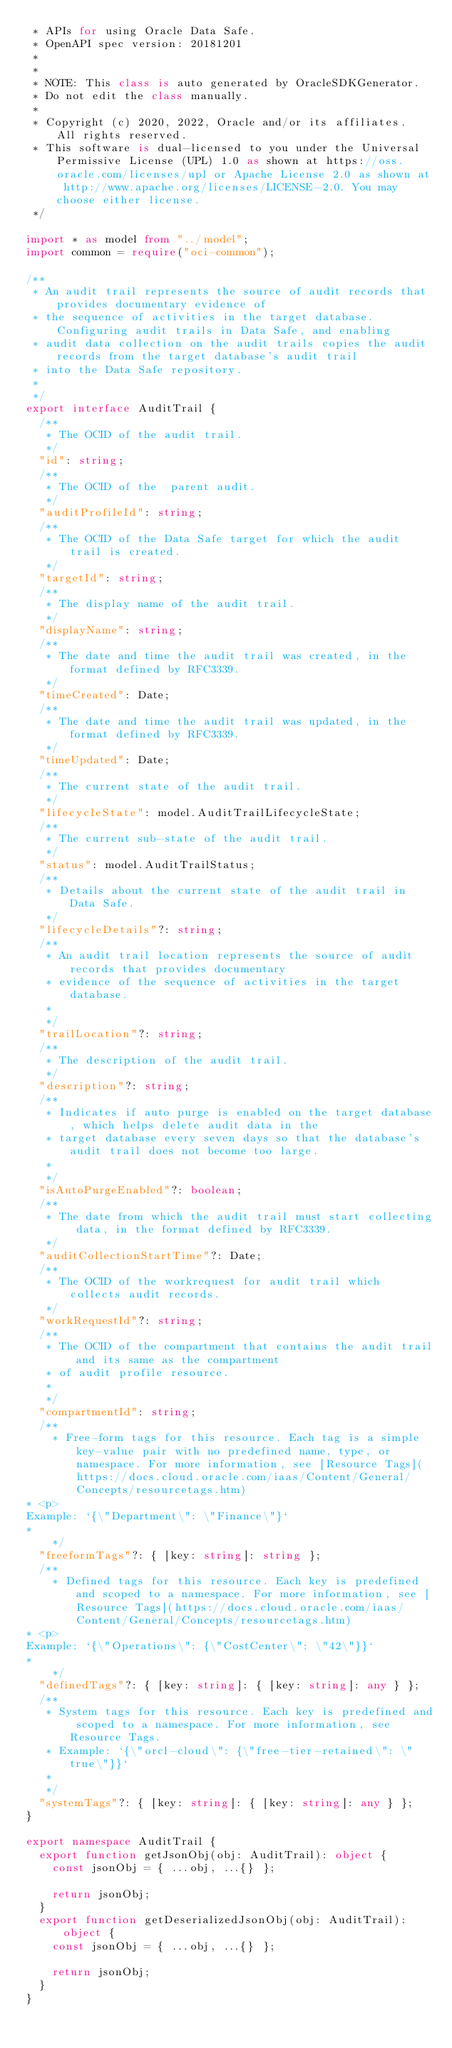Convert code to text. <code><loc_0><loc_0><loc_500><loc_500><_TypeScript_> * APIs for using Oracle Data Safe.
 * OpenAPI spec version: 20181201
 *
 *
 * NOTE: This class is auto generated by OracleSDKGenerator.
 * Do not edit the class manually.
 *
 * Copyright (c) 2020, 2022, Oracle and/or its affiliates.  All rights reserved.
 * This software is dual-licensed to you under the Universal Permissive License (UPL) 1.0 as shown at https://oss.oracle.com/licenses/upl or Apache License 2.0 as shown at http://www.apache.org/licenses/LICENSE-2.0. You may choose either license.
 */

import * as model from "../model";
import common = require("oci-common");

/**
 * An audit trail represents the source of audit records that provides documentary evidence of
 * the sequence of activities in the target database. Configuring audit trails in Data Safe, and enabling
 * audit data collection on the audit trails copies the audit records from the target database's audit trail
 * into the Data Safe repository.
 *
 */
export interface AuditTrail {
  /**
   * The OCID of the audit trail.
   */
  "id": string;
  /**
   * The OCID of the  parent audit.
   */
  "auditProfileId": string;
  /**
   * The OCID of the Data Safe target for which the audit trail is created.
   */
  "targetId": string;
  /**
   * The display name of the audit trail.
   */
  "displayName": string;
  /**
   * The date and time the audit trail was created, in the format defined by RFC3339.
   */
  "timeCreated": Date;
  /**
   * The date and time the audit trail was updated, in the format defined by RFC3339.
   */
  "timeUpdated": Date;
  /**
   * The current state of the audit trail.
   */
  "lifecycleState": model.AuditTrailLifecycleState;
  /**
   * The current sub-state of the audit trail.
   */
  "status": model.AuditTrailStatus;
  /**
   * Details about the current state of the audit trail in Data Safe.
   */
  "lifecycleDetails"?: string;
  /**
   * An audit trail location represents the source of audit records that provides documentary
   * evidence of the sequence of activities in the target database.
   *
   */
  "trailLocation"?: string;
  /**
   * The description of the audit trail.
   */
  "description"?: string;
  /**
   * Indicates if auto purge is enabled on the target database, which helps delete audit data in the
   * target database every seven days so that the database's audit trail does not become too large.
   *
   */
  "isAutoPurgeEnabled"?: boolean;
  /**
   * The date from which the audit trail must start collecting data, in the format defined by RFC3339.
   */
  "auditCollectionStartTime"?: Date;
  /**
   * The OCID of the workrequest for audit trail which collects audit records.
   */
  "workRequestId"?: string;
  /**
   * The OCID of the compartment that contains the audit trail and its same as the compartment
   * of audit profile resource.
   *
   */
  "compartmentId": string;
  /**
    * Free-form tags for this resource. Each tag is a simple key-value pair with no predefined name, type, or namespace. For more information, see [Resource Tags](https://docs.cloud.oracle.com/iaas/Content/General/Concepts/resourcetags.htm)
* <p>
Example: `{\"Department\": \"Finance\"}`
* 
    */
  "freeformTags"?: { [key: string]: string };
  /**
    * Defined tags for this resource. Each key is predefined and scoped to a namespace. For more information, see [Resource Tags](https://docs.cloud.oracle.com/iaas/Content/General/Concepts/resourcetags.htm)
* <p>
Example: `{\"Operations\": {\"CostCenter\": \"42\"}}`
* 
    */
  "definedTags"?: { [key: string]: { [key: string]: any } };
  /**
   * System tags for this resource. Each key is predefined and scoped to a namespace. For more information, see Resource Tags.
   * Example: `{\"orcl-cloud\": {\"free-tier-retained\": \"true\"}}`
   *
   */
  "systemTags"?: { [key: string]: { [key: string]: any } };
}

export namespace AuditTrail {
  export function getJsonObj(obj: AuditTrail): object {
    const jsonObj = { ...obj, ...{} };

    return jsonObj;
  }
  export function getDeserializedJsonObj(obj: AuditTrail): object {
    const jsonObj = { ...obj, ...{} };

    return jsonObj;
  }
}
</code> 